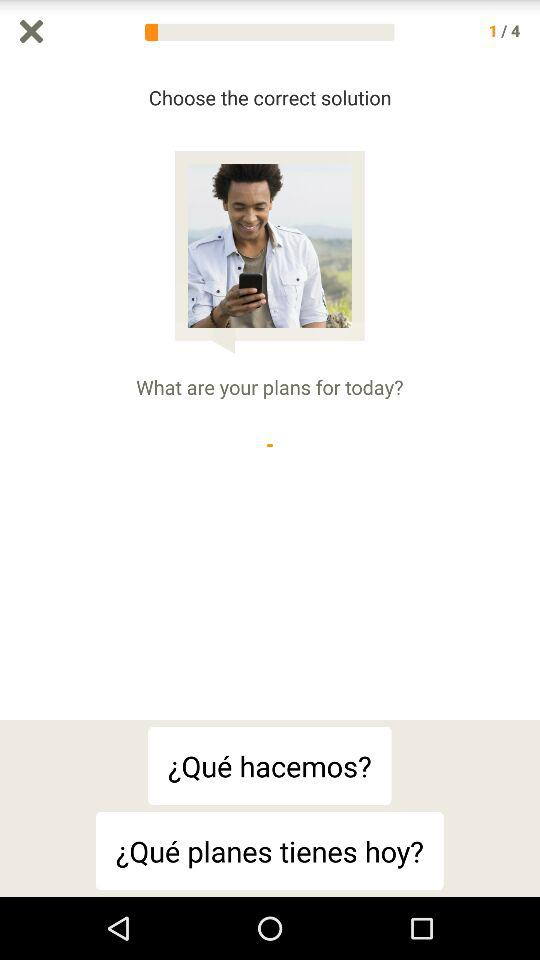What question is currently displayed? The currently displayed question is "What are your plans for today?". 